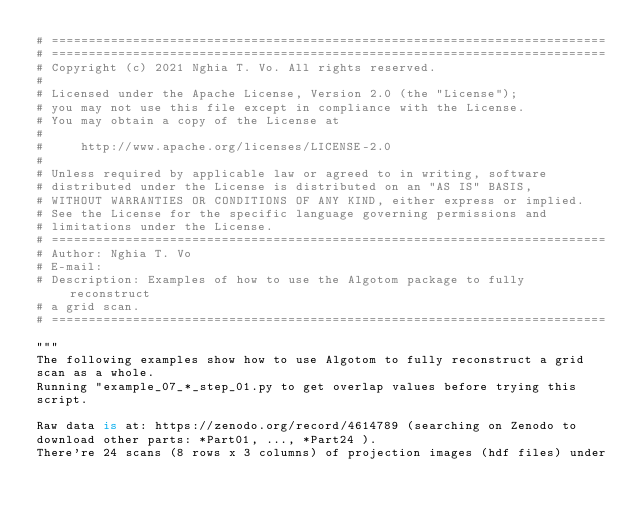<code> <loc_0><loc_0><loc_500><loc_500><_Python_># ===========================================================================
# ===========================================================================
# Copyright (c) 2021 Nghia T. Vo. All rights reserved.
#
# Licensed under the Apache License, Version 2.0 (the "License");
# you may not use this file except in compliance with the License.
# You may obtain a copy of the License at
#
#     http://www.apache.org/licenses/LICENSE-2.0
#
# Unless required by applicable law or agreed to in writing, software
# distributed under the License is distributed on an "AS IS" BASIS,
# WITHOUT WARRANTIES OR CONDITIONS OF ANY KIND, either express or implied.
# See the License for the specific language governing permissions and
# limitations under the License.
# ===========================================================================
# Author: Nghia T. Vo
# E-mail:  
# Description: Examples of how to use the Algotom package to fully reconstruct
# a grid scan.
# ===========================================================================

"""
The following examples show how to use Algotom to fully reconstruct a grid
scan as a whole.
Running "example_07_*_step_01.py to get overlap values before trying this
script.

Raw data is at: https://zenodo.org/record/4614789 (searching on Zenodo to
download other parts: *Part01, ..., *Part24 ).
There're 24 scans (8 rows x 3 columns) of projection images (hdf files) under</code> 